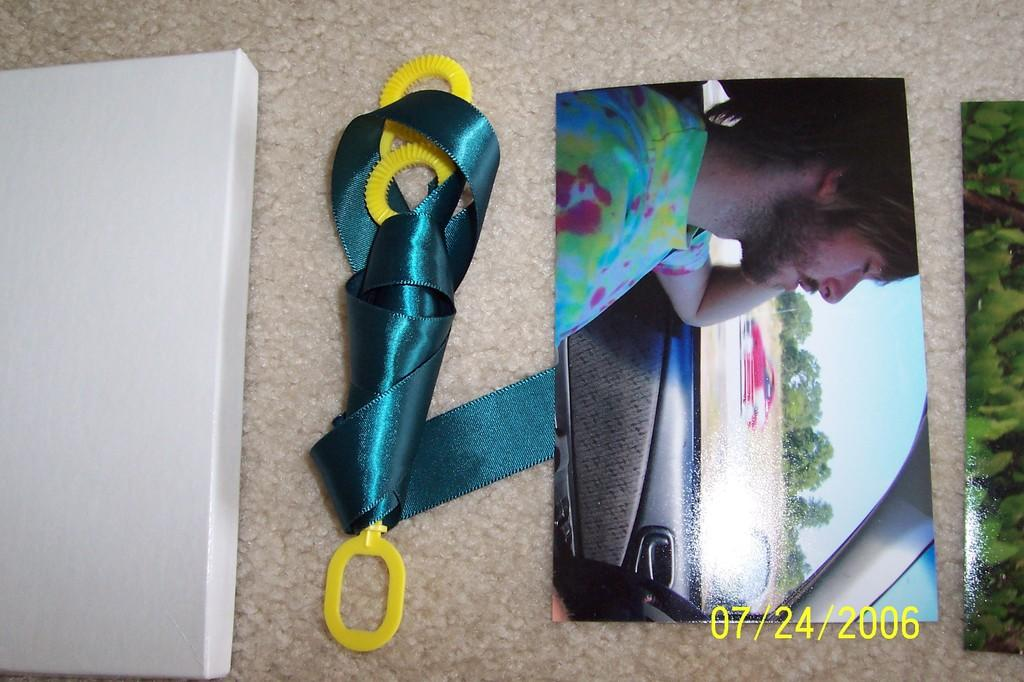What type of items can be seen in the image? There are photographs and a ribbon in the image. Are there any objects on a surface in the image? Yes, there are objects on a platform in the image. What is located in the bottom right corner of the image? There are numbers in the bottom right corner of the image. What type of railway is visible in the image? There is no railway present in the image. What year is depicted in the image? The provided facts do not mention any specific year, so it cannot be determined from the image. 